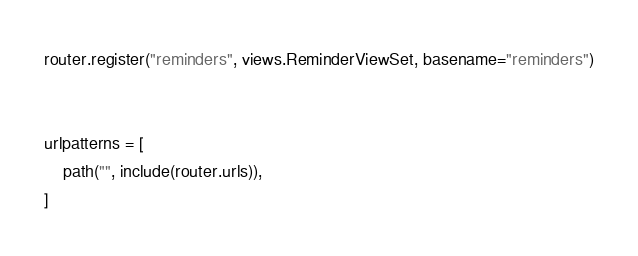<code> <loc_0><loc_0><loc_500><loc_500><_Python_>router.register("reminders", views.ReminderViewSet, basename="reminders")


urlpatterns = [
    path("", include(router.urls)),
]
</code> 